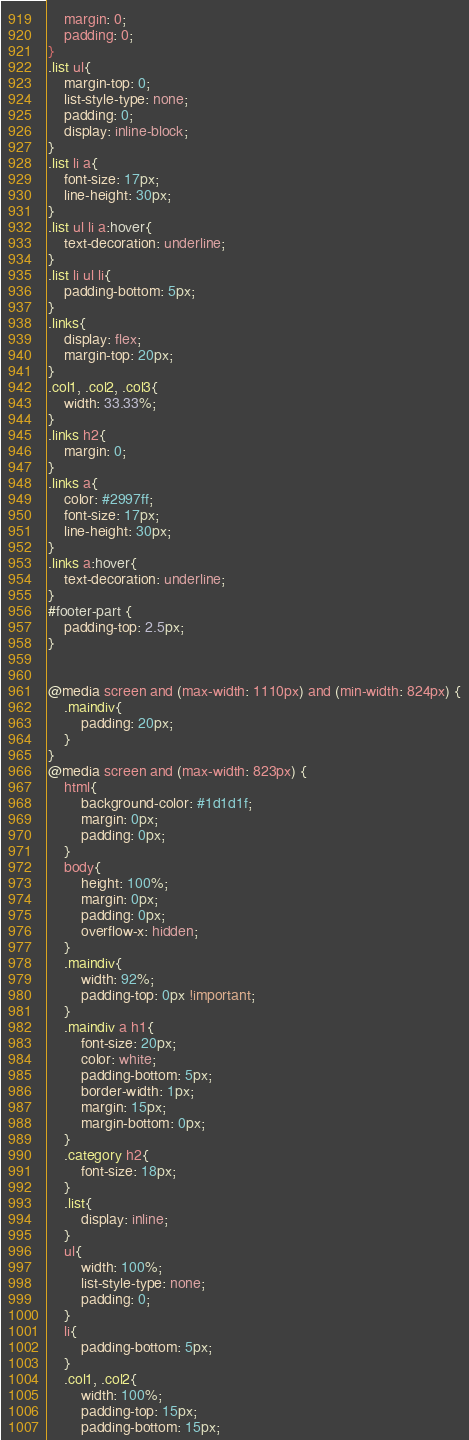Convert code to text. <code><loc_0><loc_0><loc_500><loc_500><_CSS_>    margin: 0;
    padding: 0;
}
.list ul{
    margin-top: 0;
    list-style-type: none;
    padding: 0;
    display: inline-block;
}
.list li a{
    font-size: 17px;
    line-height: 30px;
}
.list ul li a:hover{
    text-decoration: underline;
}
.list li ul li{
    padding-bottom: 5px;
}
.links{
    display: flex;
    margin-top: 20px;
}
.col1, .col2, .col3{
    width: 33.33%;
}
.links h2{
    margin: 0;
}
.links a{
    color: #2997ff;
    font-size: 17px;
    line-height: 30px;
}
.links a:hover{
    text-decoration: underline;
}
#footer-part {
    padding-top: 2.5px;
}


@media screen and (max-width: 1110px) and (min-width: 824px) {
    .maindiv{
        padding: 20px;
    }
}
@media screen and (max-width: 823px) {
    html{
        background-color: #1d1d1f;
        margin: 0px;
        padding: 0px;
    }
    body{
        height: 100%;
        margin: 0px;
        padding: 0px;
        overflow-x: hidden;
    }
    .maindiv{
        width: 92%;
        padding-top: 0px !important;
    }
    .maindiv a h1{
        font-size: 20px;
        color: white;
        padding-bottom: 5px;
        border-width: 1px;
        margin: 15px;
        margin-bottom: 0px;
    }
    .category h2{
        font-size: 18px;
    }
    .list{
        display: inline;
    }
    ul{
        width: 100%;
        list-style-type: none;
        padding: 0;
    }
    li{
        padding-bottom: 5px;
    }
    .col1, .col2{
        width: 100%;
        padding-top: 15px;
        padding-bottom: 15px;</code> 